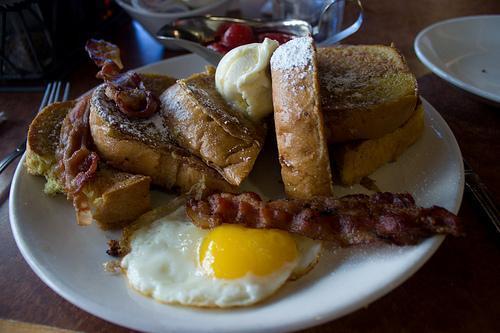How many plates?
Give a very brief answer. 2. How many forks?
Give a very brief answer. 1. 